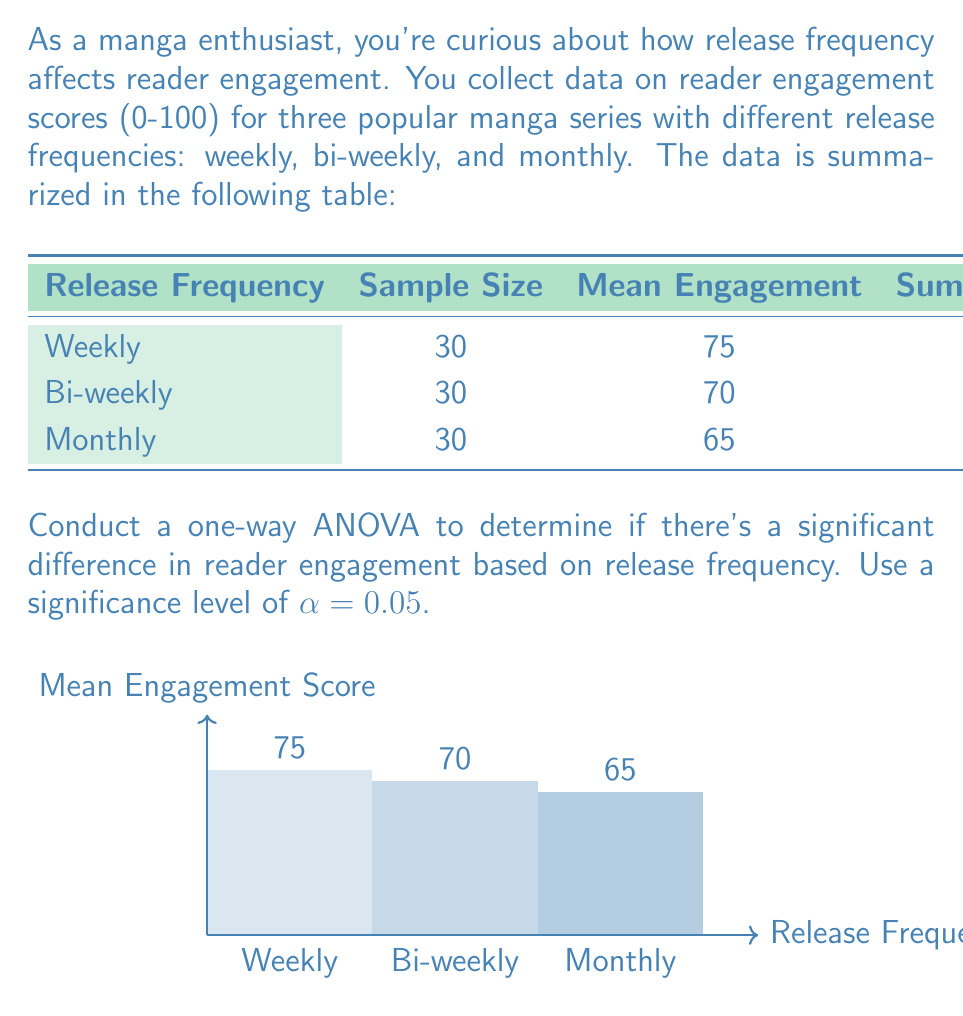Give your solution to this math problem. Let's solve this step-by-step:

1) First, we need to calculate the components of the ANOVA table:

   a) Total number of observations: $N = 30 + 30 + 30 = 90$
   b) Number of groups: $k = 3$
   c) Degrees of freedom: 
      - Between groups: $df_{between} = k - 1 = 2$
      - Within groups: $df_{within} = N - k = 87$
      - Total: $df_{total} = N - 1 = 89$

2) Calculate the Sum of Squares:

   a) Within groups (SSW): Sum of squared deviations = 2700 + 3000 + 2400 = 8100
   b) Total (SST): 
      $$SST = \sum_{i=1}^{k} \sum_{j=1}^{n_i} (X_{ij} - \bar{X})^2$$
      where $\bar{X}$ is the grand mean:
      $$\bar{X} = \frac{75 \cdot 30 + 70 \cdot 30 + 65 \cdot 30}{90} = 70$$
      $$SST = 30(75-70)^2 + 30(70-70)^2 + 30(65-70)^2 = 9000$$
   c) Between groups (SSB): SST - SSW = 9000 - 8100 = 900

3) Calculate Mean Squares:

   a) Between groups: $MSB = \frac{SSB}{df_{between}} = \frac{900}{2} = 450$
   b) Within groups: $MSW = \frac{SSW}{df_{within}} = \frac{8100}{87} \approx 93.10$

4) Calculate F-statistic:

   $$F = \frac{MSB}{MSW} = \frac{450}{93.10} \approx 4.83$$

5) Find the critical F-value:
   
   For $\alpha = 0.05$, $df_{between} = 2$, and $df_{within} = 87$, 
   the critical F-value is approximately 3.10.

6) Decision:

   Since $4.83 > 3.10$, we reject the null hypothesis.
Answer: $F(2,87) = 4.83, p < 0.05$. Significant difference in reader engagement based on release frequency. 